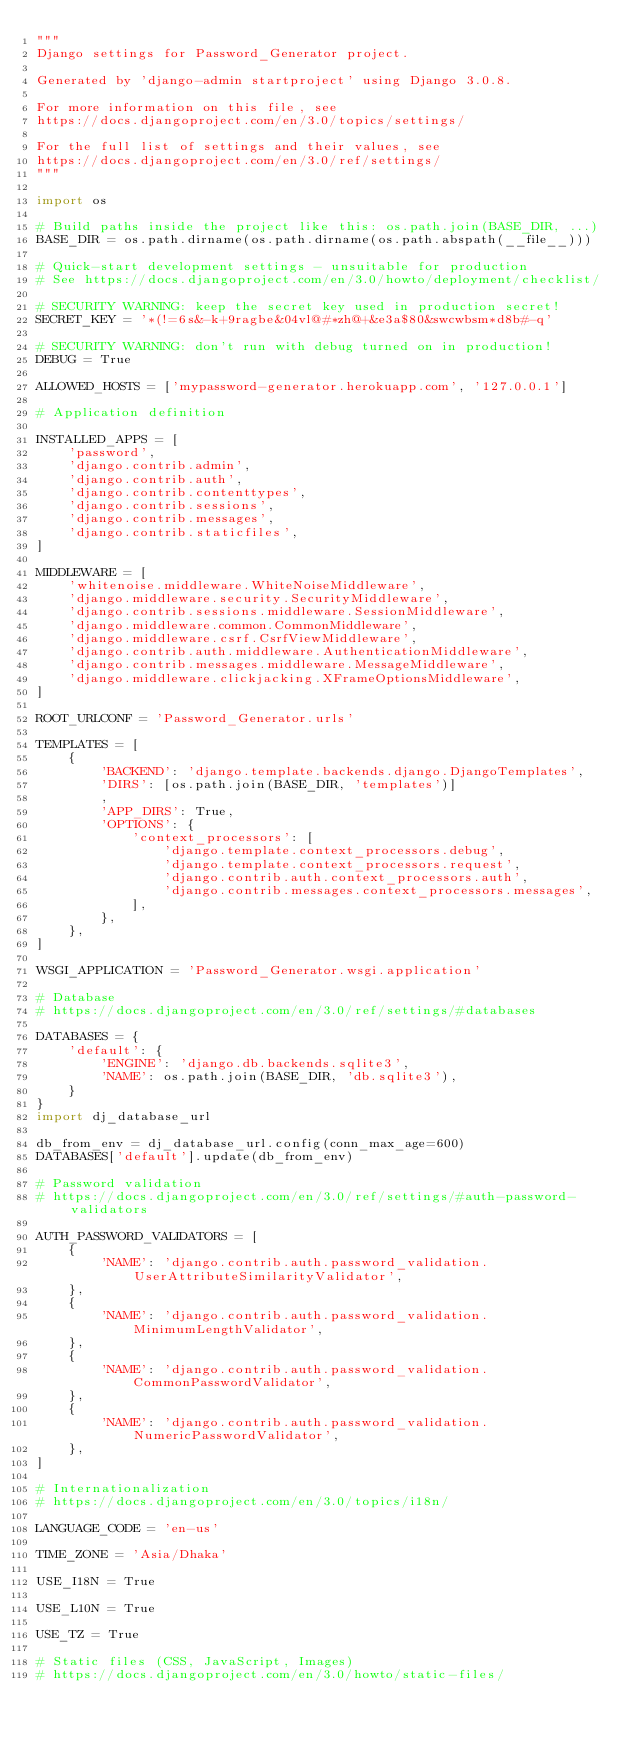Convert code to text. <code><loc_0><loc_0><loc_500><loc_500><_Python_>"""
Django settings for Password_Generator project.

Generated by 'django-admin startproject' using Django 3.0.8.

For more information on this file, see
https://docs.djangoproject.com/en/3.0/topics/settings/

For the full list of settings and their values, see
https://docs.djangoproject.com/en/3.0/ref/settings/
"""

import os

# Build paths inside the project like this: os.path.join(BASE_DIR, ...)
BASE_DIR = os.path.dirname(os.path.dirname(os.path.abspath(__file__)))

# Quick-start development settings - unsuitable for production
# See https://docs.djangoproject.com/en/3.0/howto/deployment/checklist/

# SECURITY WARNING: keep the secret key used in production secret!
SECRET_KEY = '*(!=6s&-k+9ragbe&04vl@#*zh@+&e3a$80&swcwbsm*d8b#-q'

# SECURITY WARNING: don't run with debug turned on in production!
DEBUG = True

ALLOWED_HOSTS = ['mypassword-generator.herokuapp.com', '127.0.0.1']

# Application definition

INSTALLED_APPS = [
    'password',
    'django.contrib.admin',
    'django.contrib.auth',
    'django.contrib.contenttypes',
    'django.contrib.sessions',
    'django.contrib.messages',
    'django.contrib.staticfiles',
]

MIDDLEWARE = [
    'whitenoise.middleware.WhiteNoiseMiddleware',
    'django.middleware.security.SecurityMiddleware',
    'django.contrib.sessions.middleware.SessionMiddleware',
    'django.middleware.common.CommonMiddleware',
    'django.middleware.csrf.CsrfViewMiddleware',
    'django.contrib.auth.middleware.AuthenticationMiddleware',
    'django.contrib.messages.middleware.MessageMiddleware',
    'django.middleware.clickjacking.XFrameOptionsMiddleware',
]

ROOT_URLCONF = 'Password_Generator.urls'

TEMPLATES = [
    {
        'BACKEND': 'django.template.backends.django.DjangoTemplates',
        'DIRS': [os.path.join(BASE_DIR, 'templates')]
        ,
        'APP_DIRS': True,
        'OPTIONS': {
            'context_processors': [
                'django.template.context_processors.debug',
                'django.template.context_processors.request',
                'django.contrib.auth.context_processors.auth',
                'django.contrib.messages.context_processors.messages',
            ],
        },
    },
]

WSGI_APPLICATION = 'Password_Generator.wsgi.application'

# Database
# https://docs.djangoproject.com/en/3.0/ref/settings/#databases

DATABASES = {
    'default': {
        'ENGINE': 'django.db.backends.sqlite3',
        'NAME': os.path.join(BASE_DIR, 'db.sqlite3'),
    }
}
import dj_database_url

db_from_env = dj_database_url.config(conn_max_age=600)
DATABASES['default'].update(db_from_env)

# Password validation
# https://docs.djangoproject.com/en/3.0/ref/settings/#auth-password-validators

AUTH_PASSWORD_VALIDATORS = [
    {
        'NAME': 'django.contrib.auth.password_validation.UserAttributeSimilarityValidator',
    },
    {
        'NAME': 'django.contrib.auth.password_validation.MinimumLengthValidator',
    },
    {
        'NAME': 'django.contrib.auth.password_validation.CommonPasswordValidator',
    },
    {
        'NAME': 'django.contrib.auth.password_validation.NumericPasswordValidator',
    },
]

# Internationalization
# https://docs.djangoproject.com/en/3.0/topics/i18n/

LANGUAGE_CODE = 'en-us'

TIME_ZONE = 'Asia/Dhaka'

USE_I18N = True

USE_L10N = True

USE_TZ = True

# Static files (CSS, JavaScript, Images)
# https://docs.djangoproject.com/en/3.0/howto/static-files/
</code> 